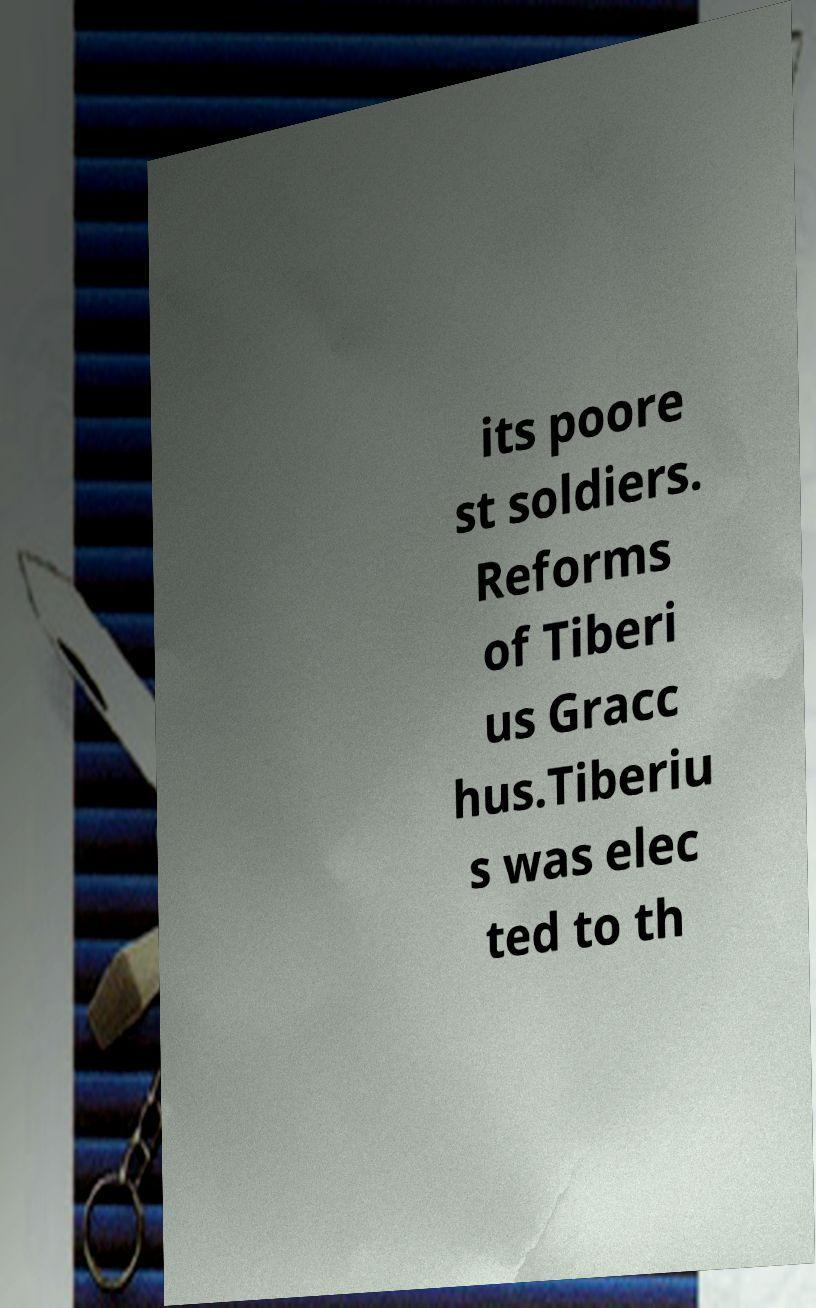What messages or text are displayed in this image? I need them in a readable, typed format. its poore st soldiers. Reforms of Tiberi us Gracc hus.Tiberiu s was elec ted to th 